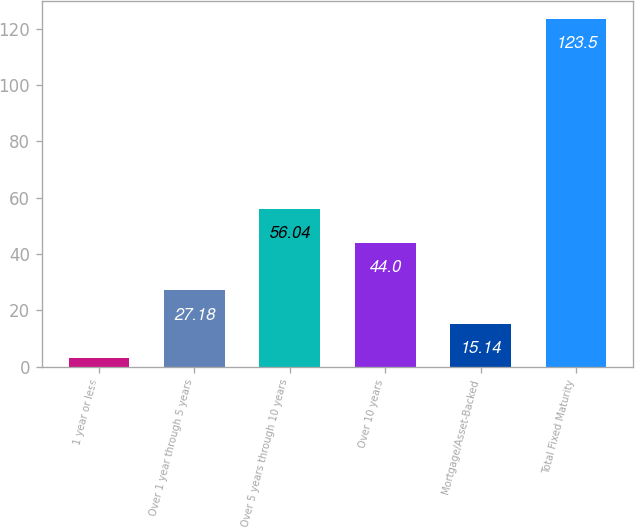Convert chart to OTSL. <chart><loc_0><loc_0><loc_500><loc_500><bar_chart><fcel>1 year or less<fcel>Over 1 year through 5 years<fcel>Over 5 years through 10 years<fcel>Over 10 years<fcel>Mortgage/Asset-Backed<fcel>Total Fixed Maturity<nl><fcel>3.1<fcel>27.18<fcel>56.04<fcel>44<fcel>15.14<fcel>123.5<nl></chart> 